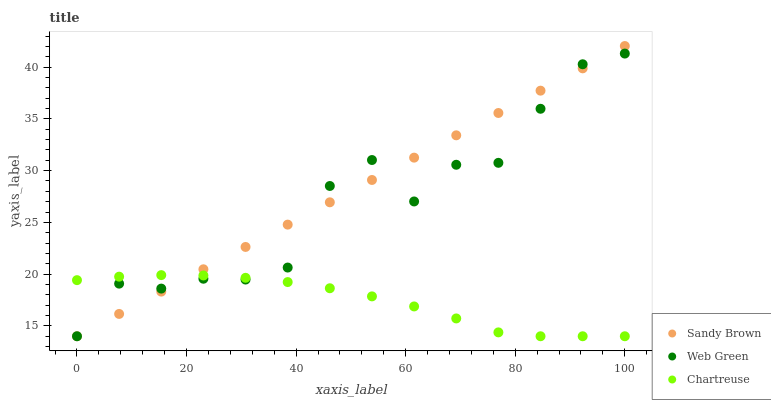Does Chartreuse have the minimum area under the curve?
Answer yes or no. Yes. Does Sandy Brown have the maximum area under the curve?
Answer yes or no. Yes. Does Web Green have the minimum area under the curve?
Answer yes or no. No. Does Web Green have the maximum area under the curve?
Answer yes or no. No. Is Sandy Brown the smoothest?
Answer yes or no. Yes. Is Web Green the roughest?
Answer yes or no. Yes. Is Web Green the smoothest?
Answer yes or no. No. Is Sandy Brown the roughest?
Answer yes or no. No. Does Chartreuse have the lowest value?
Answer yes or no. Yes. Does Sandy Brown have the highest value?
Answer yes or no. Yes. Does Web Green have the highest value?
Answer yes or no. No. Does Web Green intersect Sandy Brown?
Answer yes or no. Yes. Is Web Green less than Sandy Brown?
Answer yes or no. No. Is Web Green greater than Sandy Brown?
Answer yes or no. No. 